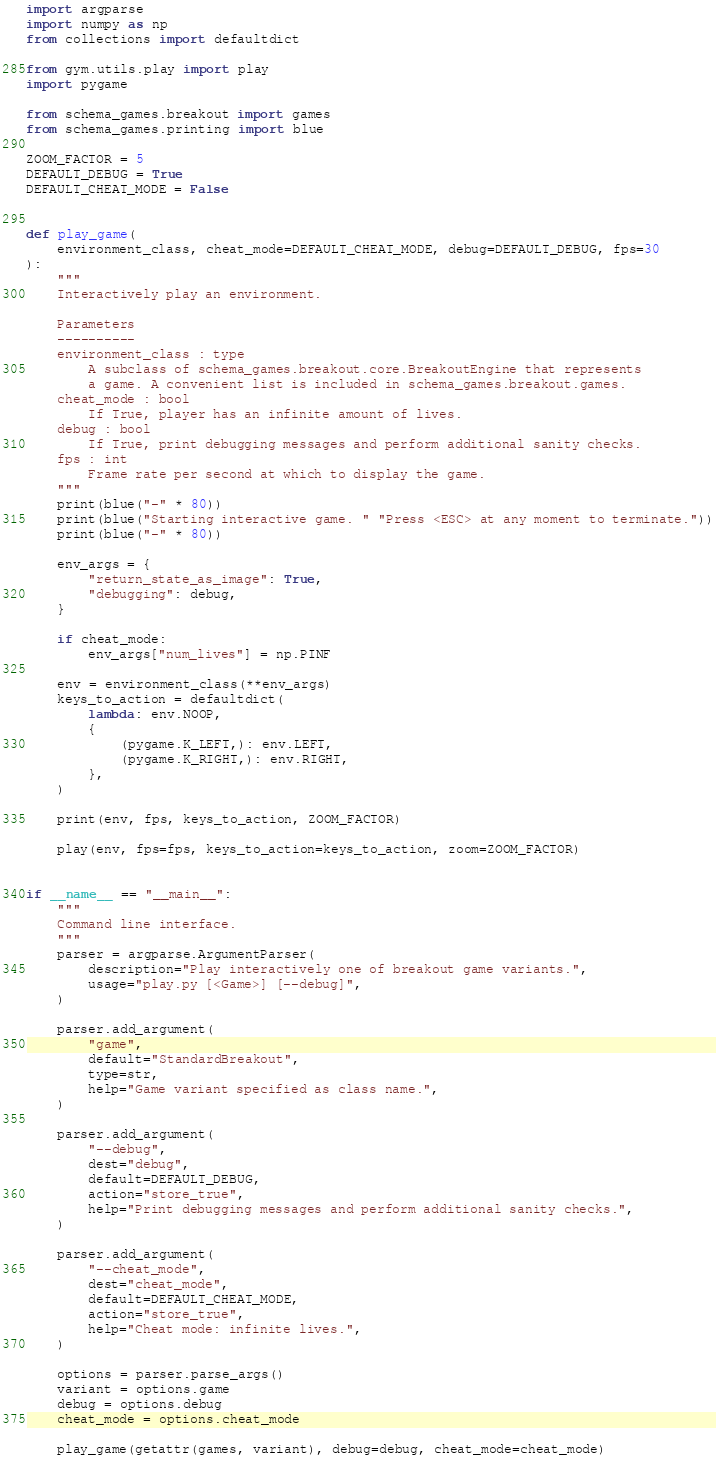Convert code to text. <code><loc_0><loc_0><loc_500><loc_500><_Python_>import argparse
import numpy as np
from collections import defaultdict

from gym.utils.play import play
import pygame

from schema_games.breakout import games
from schema_games.printing import blue

ZOOM_FACTOR = 5
DEFAULT_DEBUG = True
DEFAULT_CHEAT_MODE = False


def play_game(
    environment_class, cheat_mode=DEFAULT_CHEAT_MODE, debug=DEFAULT_DEBUG, fps=30
):
    """
    Interactively play an environment.

    Parameters
    ----------
    environment_class : type
        A subclass of schema_games.breakout.core.BreakoutEngine that represents
        a game. A convenient list is included in schema_games.breakout.games.
    cheat_mode : bool
        If True, player has an infinite amount of lives.
    debug : bool
        If True, print debugging messages and perform additional sanity checks.
    fps : int
        Frame rate per second at which to display the game.
    """
    print(blue("-" * 80))
    print(blue("Starting interactive game. " "Press <ESC> at any moment to terminate."))
    print(blue("-" * 80))

    env_args = {
        "return_state_as_image": True,
        "debugging": debug,
    }

    if cheat_mode:
        env_args["num_lives"] = np.PINF

    env = environment_class(**env_args)
    keys_to_action = defaultdict(
        lambda: env.NOOP,
        {
            (pygame.K_LEFT,): env.LEFT,
            (pygame.K_RIGHT,): env.RIGHT,
        },
    )

    print(env, fps, keys_to_action, ZOOM_FACTOR)

    play(env, fps=fps, keys_to_action=keys_to_action, zoom=ZOOM_FACTOR)


if __name__ == "__main__":
    """
    Command line interface.
    """
    parser = argparse.ArgumentParser(
        description="Play interactively one of breakout game variants.",
        usage="play.py [<Game>] [--debug]",
    )

    parser.add_argument(
        "game",
        default="StandardBreakout",
        type=str,
        help="Game variant specified as class name.",
    )

    parser.add_argument(
        "--debug",
        dest="debug",
        default=DEFAULT_DEBUG,
        action="store_true",
        help="Print debugging messages and perform additional sanity checks.",
    )

    parser.add_argument(
        "--cheat_mode",
        dest="cheat_mode",
        default=DEFAULT_CHEAT_MODE,
        action="store_true",
        help="Cheat mode: infinite lives.",
    )

    options = parser.parse_args()
    variant = options.game
    debug = options.debug
    cheat_mode = options.cheat_mode

    play_game(getattr(games, variant), debug=debug, cheat_mode=cheat_mode)
</code> 